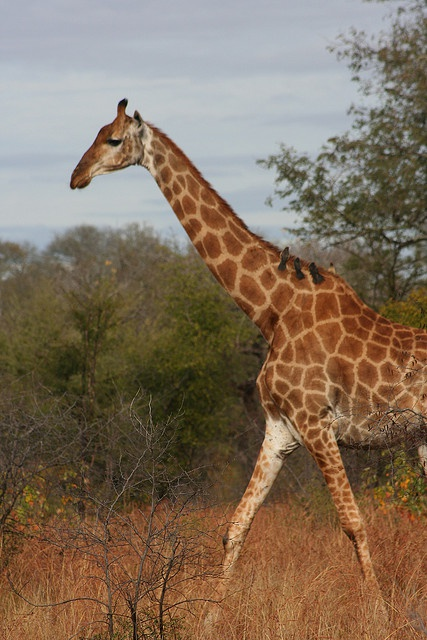Describe the objects in this image and their specific colors. I can see giraffe in darkgray, brown, maroon, and gray tones, bird in darkgray, black, maroon, and brown tones, bird in darkgray, black, and maroon tones, bird in darkgray, black, maroon, and gray tones, and bird in darkgray, gray, tan, brown, and maroon tones in this image. 